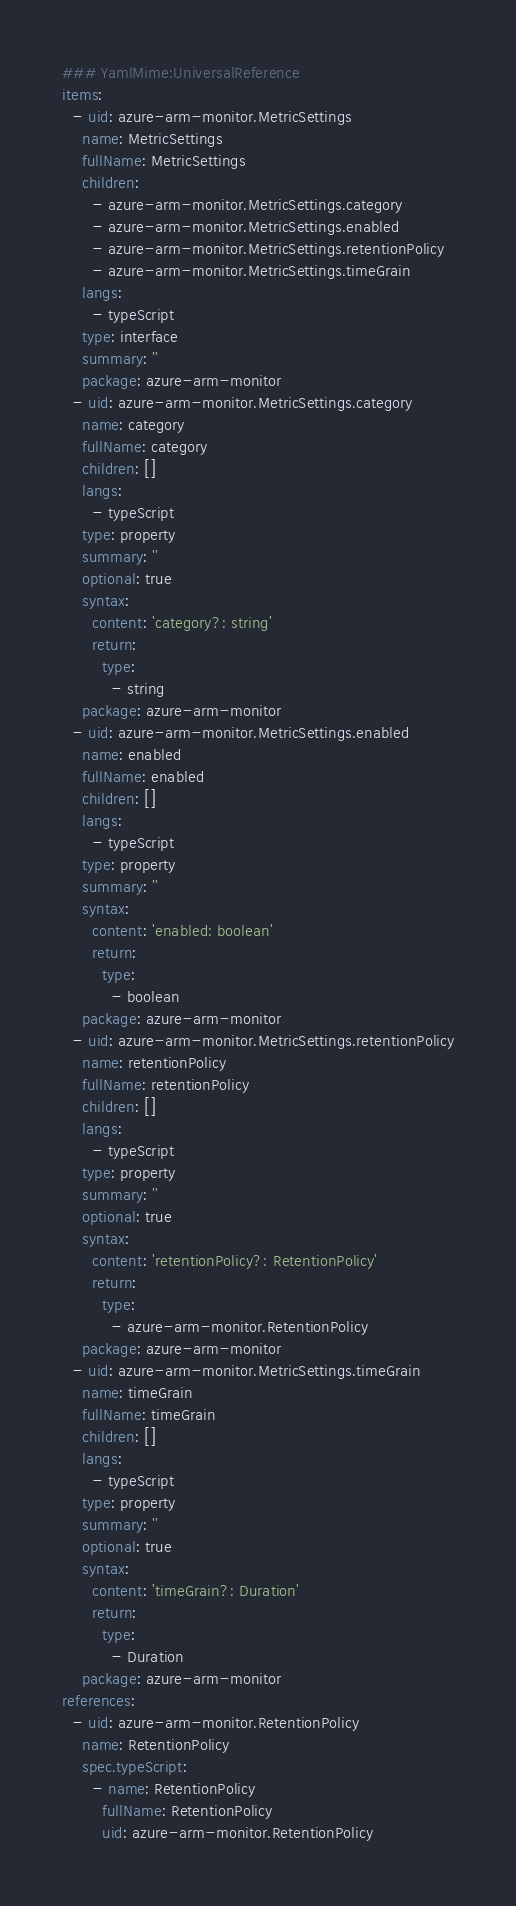<code> <loc_0><loc_0><loc_500><loc_500><_YAML_>### YamlMime:UniversalReference
items:
  - uid: azure-arm-monitor.MetricSettings
    name: MetricSettings
    fullName: MetricSettings
    children:
      - azure-arm-monitor.MetricSettings.category
      - azure-arm-monitor.MetricSettings.enabled
      - azure-arm-monitor.MetricSettings.retentionPolicy
      - azure-arm-monitor.MetricSettings.timeGrain
    langs:
      - typeScript
    type: interface
    summary: ''
    package: azure-arm-monitor
  - uid: azure-arm-monitor.MetricSettings.category
    name: category
    fullName: category
    children: []
    langs:
      - typeScript
    type: property
    summary: ''
    optional: true
    syntax:
      content: 'category?: string'
      return:
        type:
          - string
    package: azure-arm-monitor
  - uid: azure-arm-monitor.MetricSettings.enabled
    name: enabled
    fullName: enabled
    children: []
    langs:
      - typeScript
    type: property
    summary: ''
    syntax:
      content: 'enabled: boolean'
      return:
        type:
          - boolean
    package: azure-arm-monitor
  - uid: azure-arm-monitor.MetricSettings.retentionPolicy
    name: retentionPolicy
    fullName: retentionPolicy
    children: []
    langs:
      - typeScript
    type: property
    summary: ''
    optional: true
    syntax:
      content: 'retentionPolicy?: RetentionPolicy'
      return:
        type:
          - azure-arm-monitor.RetentionPolicy
    package: azure-arm-monitor
  - uid: azure-arm-monitor.MetricSettings.timeGrain
    name: timeGrain
    fullName: timeGrain
    children: []
    langs:
      - typeScript
    type: property
    summary: ''
    optional: true
    syntax:
      content: 'timeGrain?: Duration'
      return:
        type:
          - Duration
    package: azure-arm-monitor
references:
  - uid: azure-arm-monitor.RetentionPolicy
    name: RetentionPolicy
    spec.typeScript:
      - name: RetentionPolicy
        fullName: RetentionPolicy
        uid: azure-arm-monitor.RetentionPolicy
</code> 